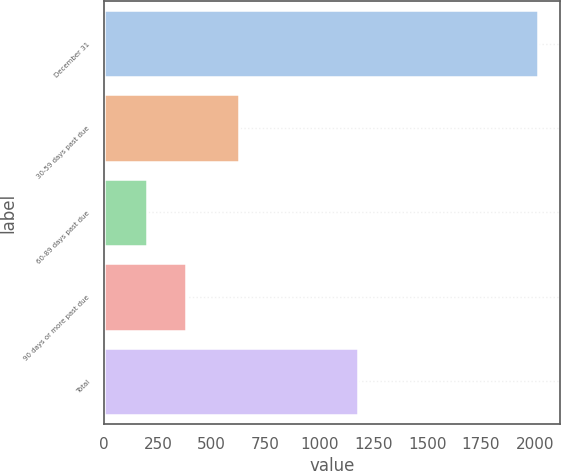Convert chart. <chart><loc_0><loc_0><loc_500><loc_500><bar_chart><fcel>December 31<fcel>30-59 days past due<fcel>60-89 days past due<fcel>90 days or more past due<fcel>Total<nl><fcel>2014<fcel>626<fcel>201<fcel>382.3<fcel>1179<nl></chart> 